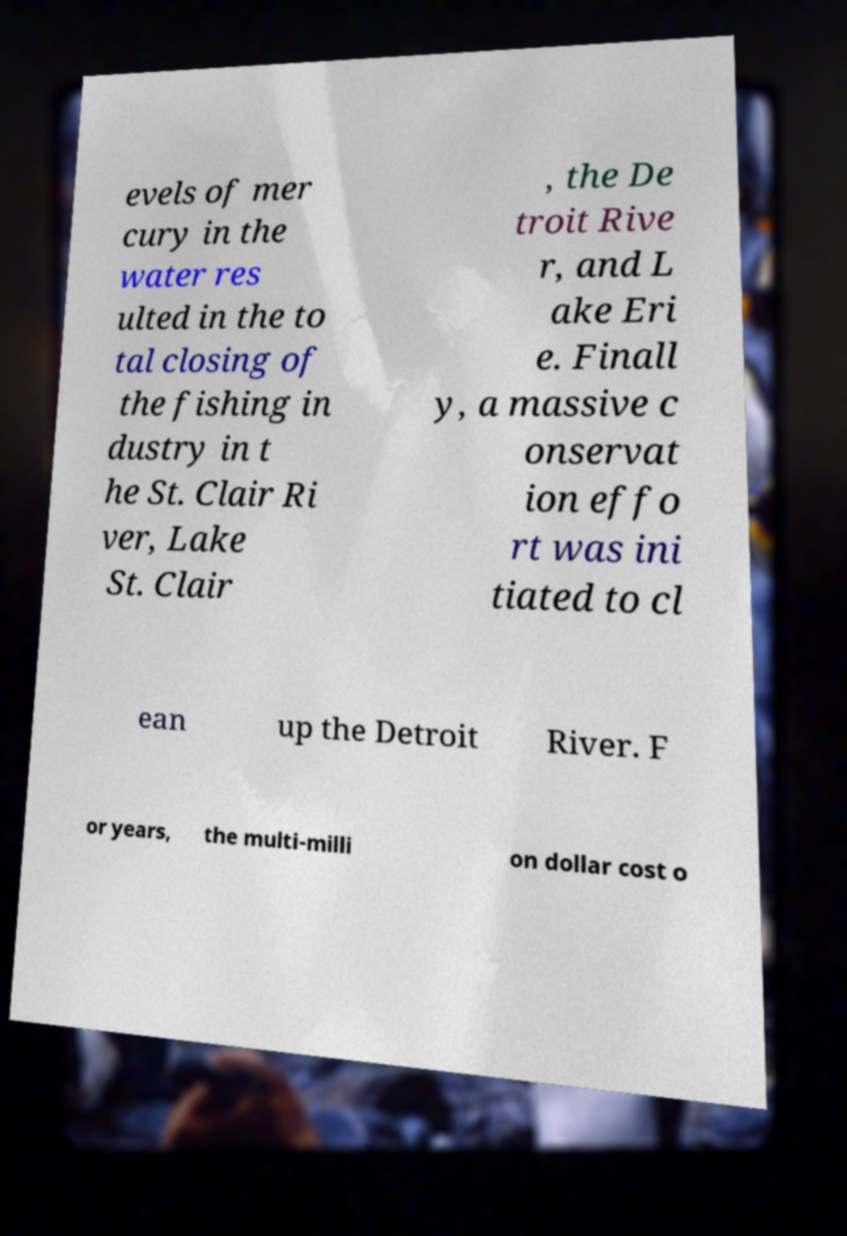There's text embedded in this image that I need extracted. Can you transcribe it verbatim? evels of mer cury in the water res ulted in the to tal closing of the fishing in dustry in t he St. Clair Ri ver, Lake St. Clair , the De troit Rive r, and L ake Eri e. Finall y, a massive c onservat ion effo rt was ini tiated to cl ean up the Detroit River. F or years, the multi-milli on dollar cost o 